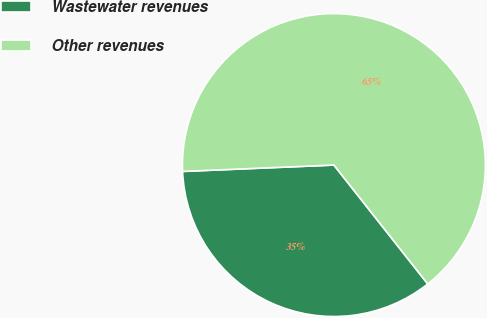Convert chart. <chart><loc_0><loc_0><loc_500><loc_500><pie_chart><fcel>Wastewater revenues<fcel>Other revenues<nl><fcel>34.96%<fcel>65.04%<nl></chart> 